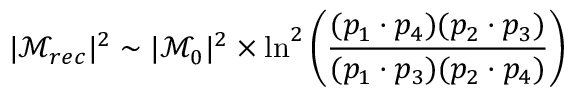Convert formula to latex. <formula><loc_0><loc_0><loc_500><loc_500>| \mathcal { M } _ { r e c } | ^ { 2 } \sim | \mathcal { M } _ { 0 } | ^ { 2 } \times \ln ^ { 2 } \left ( \frac { ( p _ { 1 } \cdot p _ { 4 } ) ( p _ { 2 } \cdot p _ { 3 } ) } { ( p _ { 1 } \cdot p _ { 3 } ) ( p _ { 2 } \cdot p _ { 4 } ) } \right )</formula> 